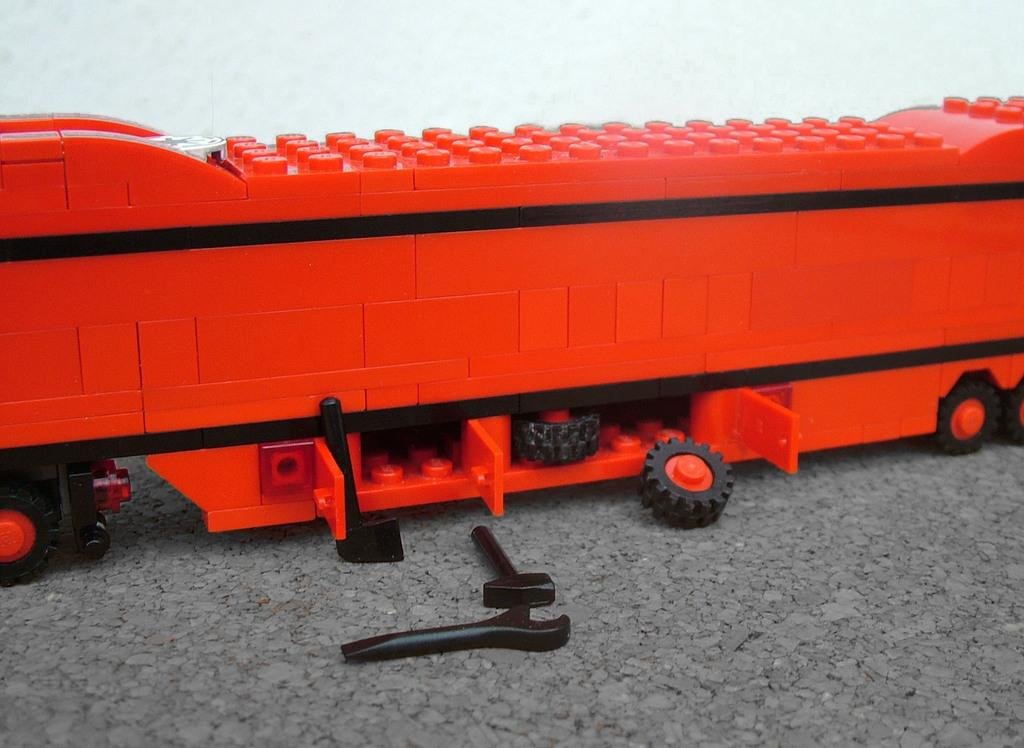What type of toy is on the floor in the image? There is a vehicle toy on the floor in the image. What additional features does the vehicle toy have? The vehicle toy has tool toys and tires on it. What can be seen in the background of the image? There is a wall in the background of the image. Can you see a monkey playing with the wire in the image? There is no monkey or wire present in the image. 